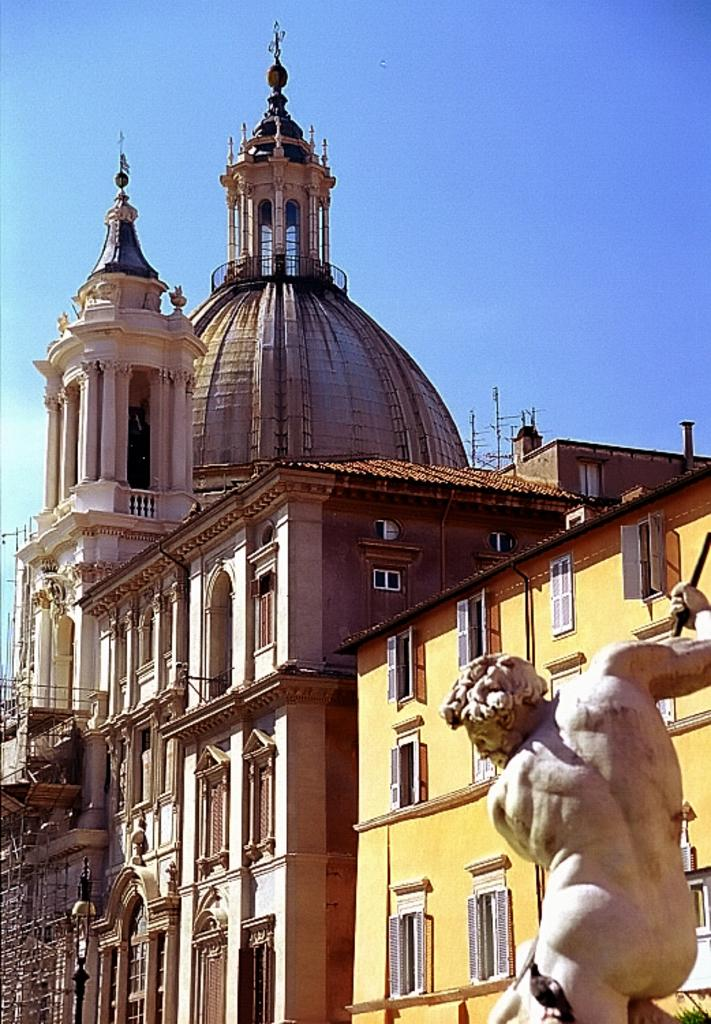What type of structure is present in the image? There is a building in the image. Can you describe any other objects or features in the image? Yes, there is a statue located in the bottom right of the image. What can be seen in the background of the image? The sky is visible at the top of the image. How quiet is the sound coming from the wall in the image? There is no wall or sound present in the image. 